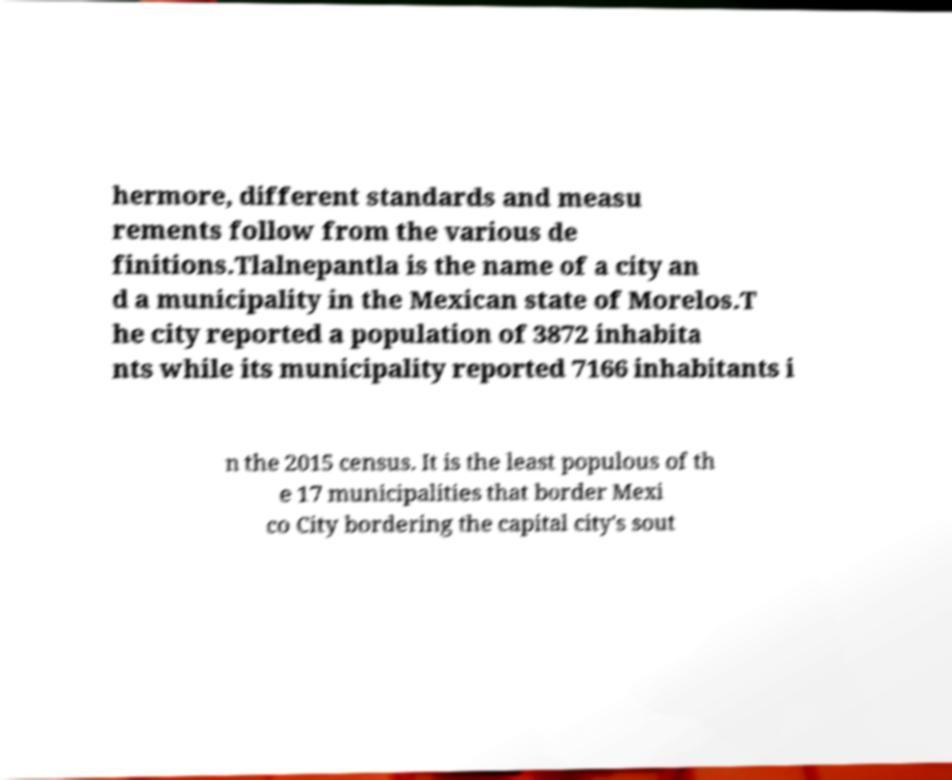Please read and relay the text visible in this image. What does it say? hermore, different standards and measu rements follow from the various de finitions.Tlalnepantla is the name of a city an d a municipality in the Mexican state of Morelos.T he city reported a population of 3872 inhabita nts while its municipality reported 7166 inhabitants i n the 2015 census. It is the least populous of th e 17 municipalities that border Mexi co City bordering the capital city's sout 